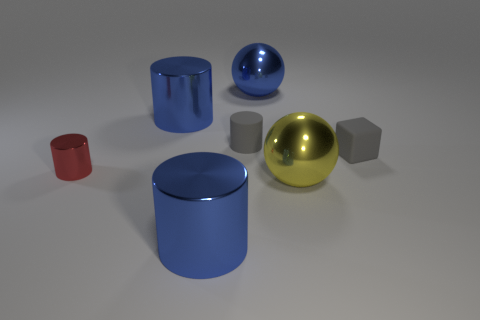There is a small object that is to the right of the gray rubber thing behind the small gray matte cube; what is it made of?
Offer a very short reply. Rubber. What size is the blue metallic cylinder right of the blue metallic cylinder that is to the left of the large cylinder that is in front of the small red metallic cylinder?
Make the answer very short. Large. How many other things are there of the same shape as the small red shiny thing?
Your answer should be very brief. 3. Do the large cylinder in front of the matte cylinder and the ball behind the small red metal thing have the same color?
Provide a short and direct response. Yes. What is the color of the matte cylinder that is the same size as the matte block?
Offer a very short reply. Gray. Are there any rubber cubes of the same color as the tiny matte cylinder?
Your response must be concise. Yes. Is the size of the ball that is in front of the red thing the same as the big blue sphere?
Offer a very short reply. Yes. Is the number of yellow balls to the right of the tiny matte cube the same as the number of small matte cubes?
Give a very brief answer. No. How many things are blue things behind the yellow metal thing or gray cylinders?
Provide a succinct answer. 3. There is a object that is both in front of the rubber cylinder and behind the tiny red shiny object; what is its shape?
Offer a terse response. Cube. 